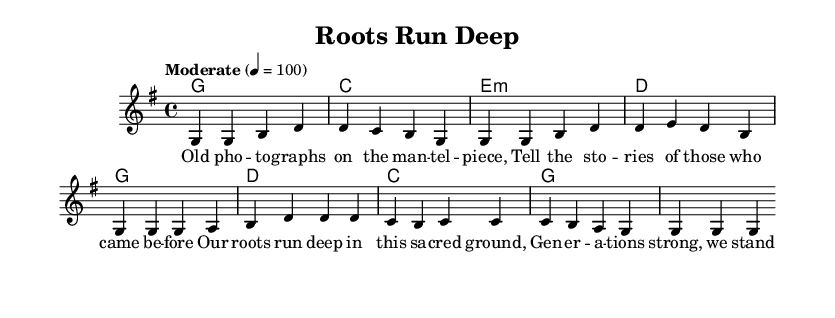What is the key signature of this music? The key signature indicated at the beginning of the score is G major, which contains one sharp (F#).
Answer: G major What is the time signature of this piece? The time signature shown in the first measure indicates that there are four beats per measure, which is notated as 4/4.
Answer: 4/4 What is the tempo marking for this composition? The tempo marking states "Moderate" with a metronome marking of quarter note equals 100, indicating the speed at which the piece should be played.
Answer: Moderate 4 = 100 How many measures are in the verse section? By counting the measures in the melody section labeled as the verse, there are four measures.
Answer: 4 What chord follows the G chord in the verse? The sequence of chords in the verse shows that after the G chord, the next chord is C in the second measure according to the harmonies provided.
Answer: C How does the melody predominantly move in the chorus? Analyzing the melody in the chorus, the notes mostly step up sequentially from G to A and back down, creating a simple yet effective melodic contour typical in country rock.
Answer: G to A What themes does the song address based on the lyrics? Looking at the lyrics, the content reveals themes of community roots and family legacies, as it speaks about historical connections and pride in ancestry.
Answer: Community roots and family legacies 